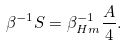Convert formula to latex. <formula><loc_0><loc_0><loc_500><loc_500>\beta ^ { - 1 } S = \beta _ { H m } ^ { - 1 } { \frac { A } { 4 } } .</formula> 